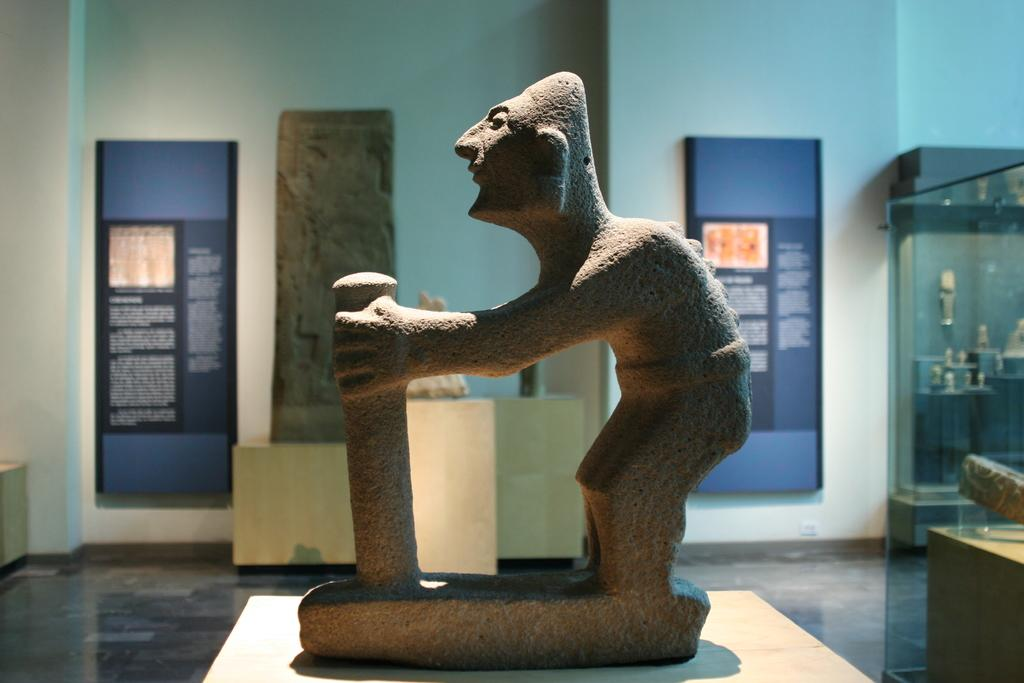What type of art is present in the image? There are sculptures in the image. What material can be seen in the image that is used for displaying information or artwork? There are boards in the image. What architectural feature is visible in the image? There is a wall in the image. What type of material is present on the right side of the image that allows for visibility? There is a transparent glass on the right side of the image. What other objects can be seen on the right side of the image? There are other objects visible on the right side of the image. How many chairs are present in the image? There is no mention of chairs in the provided facts, so we cannot determine the number of chairs in the image. What type of sand can be seen in the image? There is no sand present in the image. 